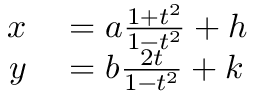Convert formula to latex. <formula><loc_0><loc_0><loc_500><loc_500>\begin{array} { r l } { x } & = a { \frac { 1 + t ^ { 2 } } { 1 - t ^ { 2 } } } + h } \\ { y } & = b { \frac { 2 t } { 1 - t ^ { 2 } } } + k } \end{array}</formula> 